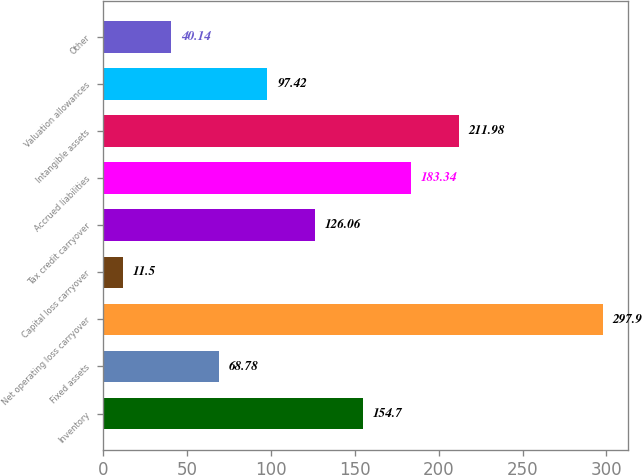<chart> <loc_0><loc_0><loc_500><loc_500><bar_chart><fcel>Inventory<fcel>Fixed assets<fcel>Net operating loss carryover<fcel>Capital loss carryover<fcel>Tax credit carryover<fcel>Accrued liabilities<fcel>Intangible assets<fcel>Valuation allowances<fcel>Other<nl><fcel>154.7<fcel>68.78<fcel>297.9<fcel>11.5<fcel>126.06<fcel>183.34<fcel>211.98<fcel>97.42<fcel>40.14<nl></chart> 